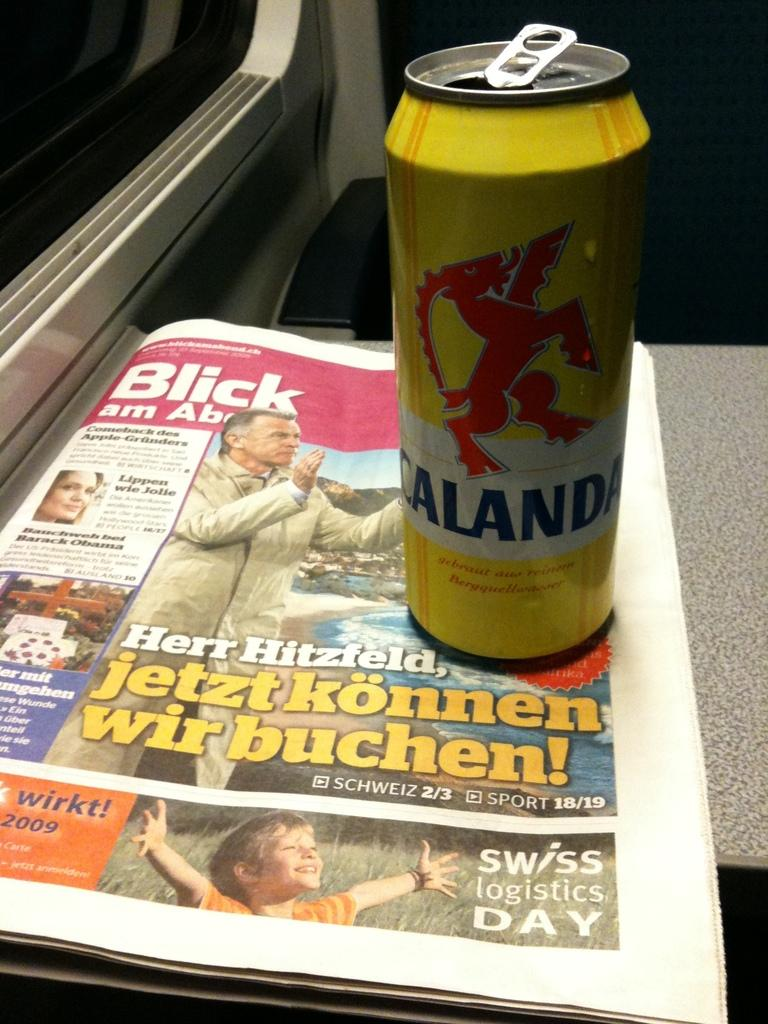Provide a one-sentence caption for the provided image. A can of Calanda drink sits on top of a newspaper that advertises Swiss Logistics Day. 